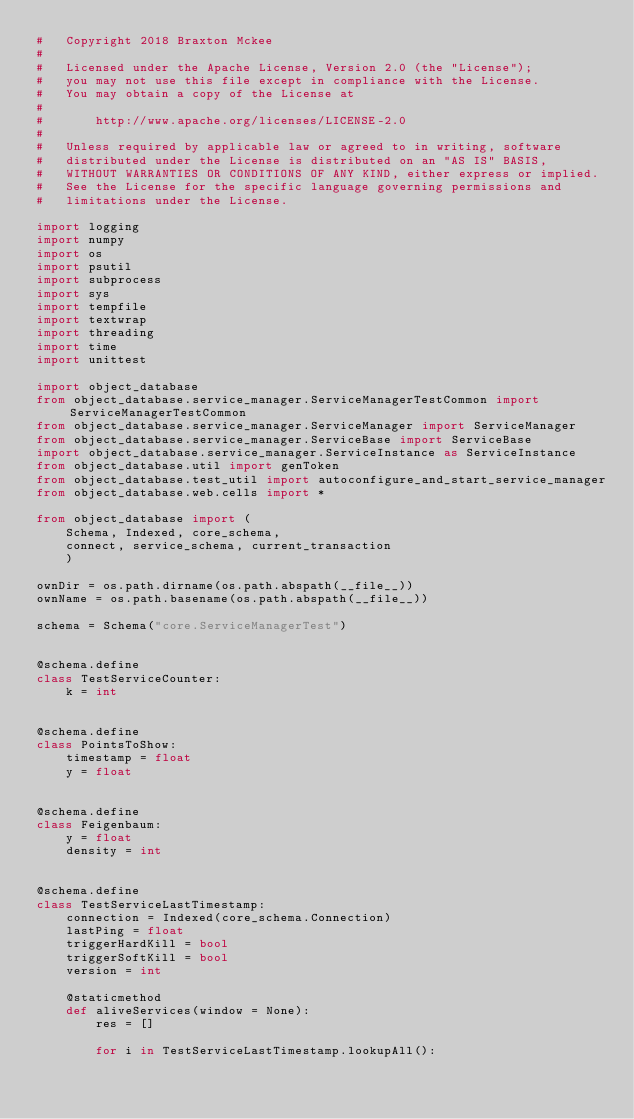<code> <loc_0><loc_0><loc_500><loc_500><_Python_>#   Copyright 2018 Braxton Mckee
#
#   Licensed under the Apache License, Version 2.0 (the "License");
#   you may not use this file except in compliance with the License.
#   You may obtain a copy of the License at
#
#       http://www.apache.org/licenses/LICENSE-2.0
#
#   Unless required by applicable law or agreed to in writing, software
#   distributed under the License is distributed on an "AS IS" BASIS,
#   WITHOUT WARRANTIES OR CONDITIONS OF ANY KIND, either express or implied.
#   See the License for the specific language governing permissions and
#   limitations under the License.

import logging
import numpy
import os
import psutil
import subprocess
import sys
import tempfile
import textwrap
import threading
import time
import unittest

import object_database
from object_database.service_manager.ServiceManagerTestCommon import ServiceManagerTestCommon
from object_database.service_manager.ServiceManager import ServiceManager
from object_database.service_manager.ServiceBase import ServiceBase
import object_database.service_manager.ServiceInstance as ServiceInstance
from object_database.util import genToken
from object_database.test_util import autoconfigure_and_start_service_manager
from object_database.web.cells import *

from object_database import (
    Schema, Indexed, core_schema,
    connect, service_schema, current_transaction
    )

ownDir = os.path.dirname(os.path.abspath(__file__))
ownName = os.path.basename(os.path.abspath(__file__))

schema = Schema("core.ServiceManagerTest")


@schema.define
class TestServiceCounter:
    k = int


@schema.define
class PointsToShow:
    timestamp = float
    y = float


@schema.define
class Feigenbaum:
    y = float
    density = int


@schema.define
class TestServiceLastTimestamp:
    connection = Indexed(core_schema.Connection)
    lastPing = float
    triggerHardKill = bool
    triggerSoftKill = bool
    version = int

    @staticmethod
    def aliveServices(window = None):
        res = []

        for i in TestServiceLastTimestamp.lookupAll():</code> 